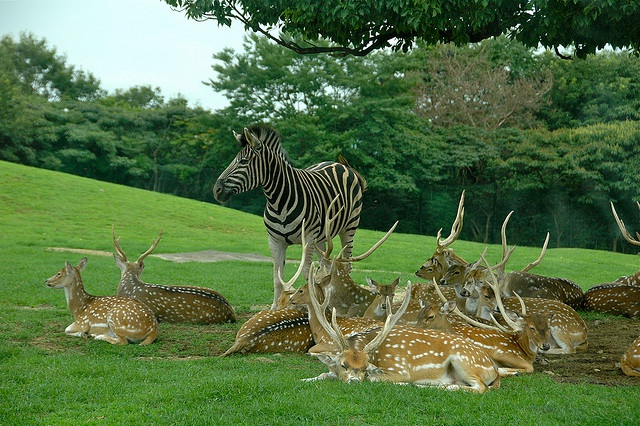Describe the objects in this image and their specific colors. I can see a zebra in lightblue, black, gray, olive, and darkgreen tones in this image. 